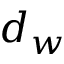Convert formula to latex. <formula><loc_0><loc_0><loc_500><loc_500>d _ { w }</formula> 